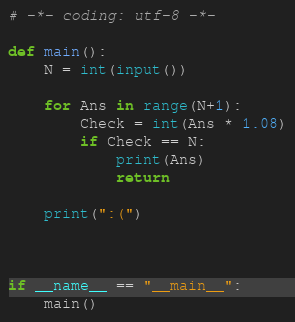<code> <loc_0><loc_0><loc_500><loc_500><_Python_># -*- coding: utf-8 -*-

def main():
    N = int(input())

    for Ans in range(N+1):
        Check = int(Ans * 1.08)
        if Check == N:
            print(Ans)
            return

    print(":(")
        


if __name__ == "__main__":
    main()
</code> 